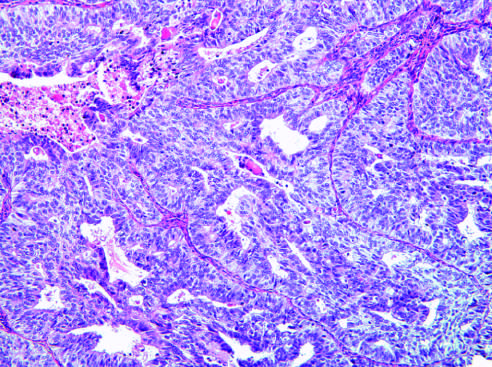what does endometrioid type, grade 3, have?
Answer the question using a single word or phrase. A predominantly solid growth pattern 